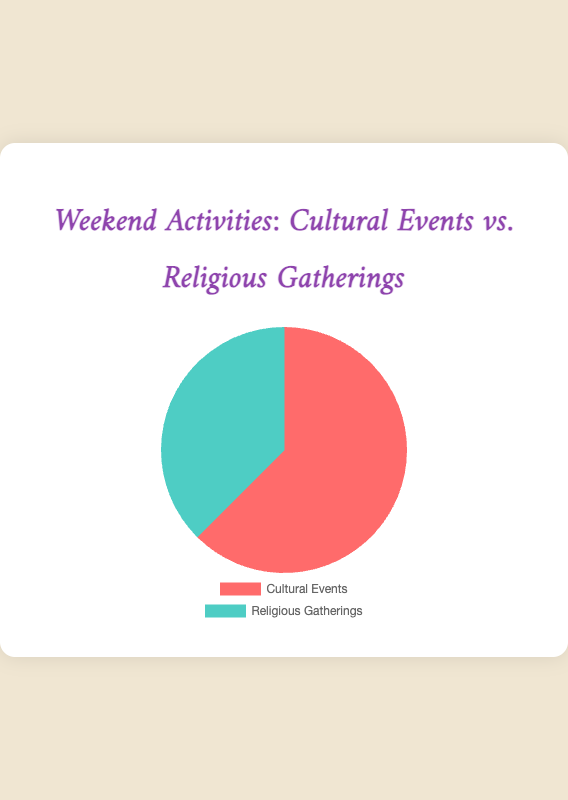What are the two categories shown in the pie chart? The pie chart displays two categories: "Cultural Events" and "Religious Gatherings".
Answer: Cultural Events, Religious Gatherings Which category has a higher percentage? By visually comparing the two slices, the 'Cultural Events' slice is larger than the 'Religious Gatherings' slice.
Answer: Cultural Events What is the total percentage for "Cultural Events"? The numeric data presented states that "Cultural Events" account for 75% of the total.
Answer: 75% How much larger is the percentage of "Cultural Events" compared to "Religious Gatherings"? "Cultural Events" have a percentage of 75%, while "Religious Gatherings" have 45%. The difference is calculated as 75% - 45%.
Answer: 30% What percentage is allocated to "Religious Gatherings"? The numeric data shown states that "Religious Gatherings" account for 45% of the total.
Answer: 45% Which event has a higher percentage: "Museum Visits" or "Friday Prayer (Jumu'ah)"? "Museum Visits" is part of Cultural Events with 25%, and "Friday Prayer (Jumu'ah)" is part of Religious Gatherings with 35%. Comparing these two, 35% is larger than 25%.
Answer: Friday Prayer (Jumu'ah) What visual attribute indicates that "Cultural Events" take up a larger proportion of the pie chart? The "Cultural Events" slice is noticeably larger in area compared to the "Religious Gatherings" slice.
Answer: Larger slice If we combined "Islamic Study Circles (Halaqas)" and "Community Iftars", what would be their total percentage? "Islamic Study Circles (Halaqas)" has 15% and "Community Iftars" has 10%. The sum is 15% + 10%.
Answer: 25% Is the sum of the total percentages for "Cultural Events" and "Religious Gatherings" greater than 100%? "Cultural Events" have 75% and "Religious Gatherings" have 45%. The sum is 75% + 45% = 120%, which is greater than 100%.
Answer: Yes 